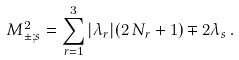Convert formula to latex. <formula><loc_0><loc_0><loc_500><loc_500>M ^ { 2 } _ { \pm ; s } = \sum _ { r = 1 } ^ { 3 } | \lambda _ { r } | ( 2 \, N _ { r } + 1 ) \mp 2 \lambda _ { s } \, .</formula> 